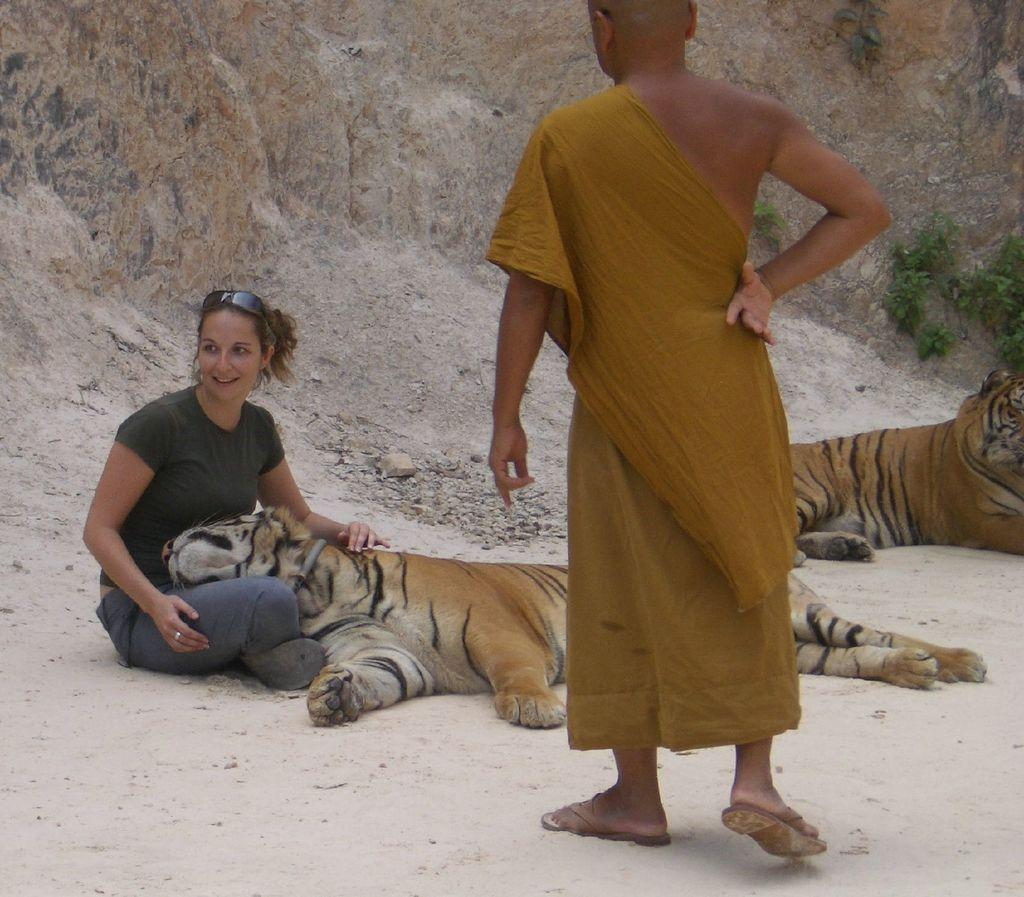What is the position of the person in the image? There is a person sitting on the ground in the image. Can you describe the other person in the image? There is a person standing in the image. What other living beings are present in the image? There are animals in the image. What can be seen in the background of the image? There is a rock and plants in the background of the image. What type of straw is being used by the person sitting on the ground in the image? There is no straw visible in the image; the person sitting on the ground is not using any straw. Can you describe the arch in the image? There is no arch present in the image. 